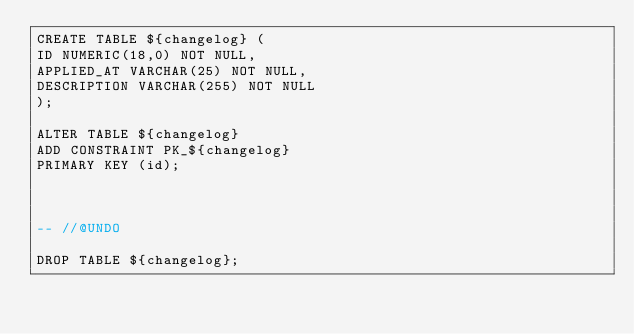Convert code to text. <code><loc_0><loc_0><loc_500><loc_500><_SQL_>CREATE TABLE ${changelog} (
ID NUMERIC(18,0) NOT NULL,
APPLIED_AT VARCHAR(25) NOT NULL,
DESCRIPTION VARCHAR(255) NOT NULL
);

ALTER TABLE ${changelog}
ADD CONSTRAINT PK_${changelog}
PRIMARY KEY (id);



-- //@UNDO

DROP TABLE ${changelog};

</code> 